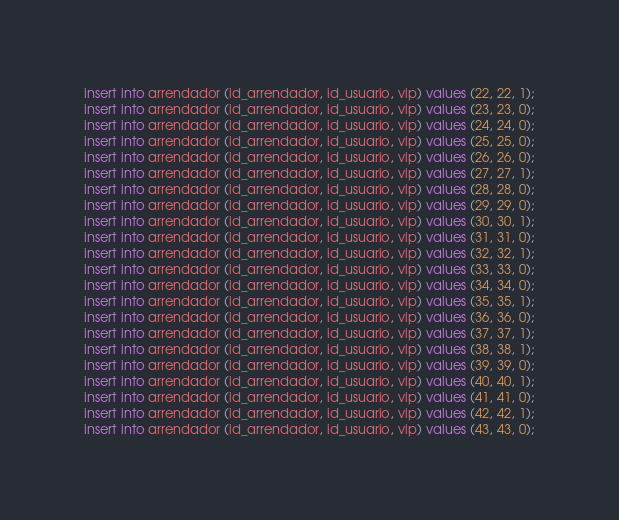<code> <loc_0><loc_0><loc_500><loc_500><_SQL_>insert into arrendador (id_arrendador, id_usuario, vip) values (22, 22, 1);
insert into arrendador (id_arrendador, id_usuario, vip) values (23, 23, 0);
insert into arrendador (id_arrendador, id_usuario, vip) values (24, 24, 0);
insert into arrendador (id_arrendador, id_usuario, vip) values (25, 25, 0);
insert into arrendador (id_arrendador, id_usuario, vip) values (26, 26, 0);
insert into arrendador (id_arrendador, id_usuario, vip) values (27, 27, 1);
insert into arrendador (id_arrendador, id_usuario, vip) values (28, 28, 0);
insert into arrendador (id_arrendador, id_usuario, vip) values (29, 29, 0);
insert into arrendador (id_arrendador, id_usuario, vip) values (30, 30, 1);
insert into arrendador (id_arrendador, id_usuario, vip) values (31, 31, 0);
insert into arrendador (id_arrendador, id_usuario, vip) values (32, 32, 1);
insert into arrendador (id_arrendador, id_usuario, vip) values (33, 33, 0);
insert into arrendador (id_arrendador, id_usuario, vip) values (34, 34, 0);
insert into arrendador (id_arrendador, id_usuario, vip) values (35, 35, 1);
insert into arrendador (id_arrendador, id_usuario, vip) values (36, 36, 0);
insert into arrendador (id_arrendador, id_usuario, vip) values (37, 37, 1);
insert into arrendador (id_arrendador, id_usuario, vip) values (38, 38, 1);
insert into arrendador (id_arrendador, id_usuario, vip) values (39, 39, 0);
insert into arrendador (id_arrendador, id_usuario, vip) values (40, 40, 1);
insert into arrendador (id_arrendador, id_usuario, vip) values (41, 41, 0);
insert into arrendador (id_arrendador, id_usuario, vip) values (42, 42, 1);
insert into arrendador (id_arrendador, id_usuario, vip) values (43, 43, 0);</code> 